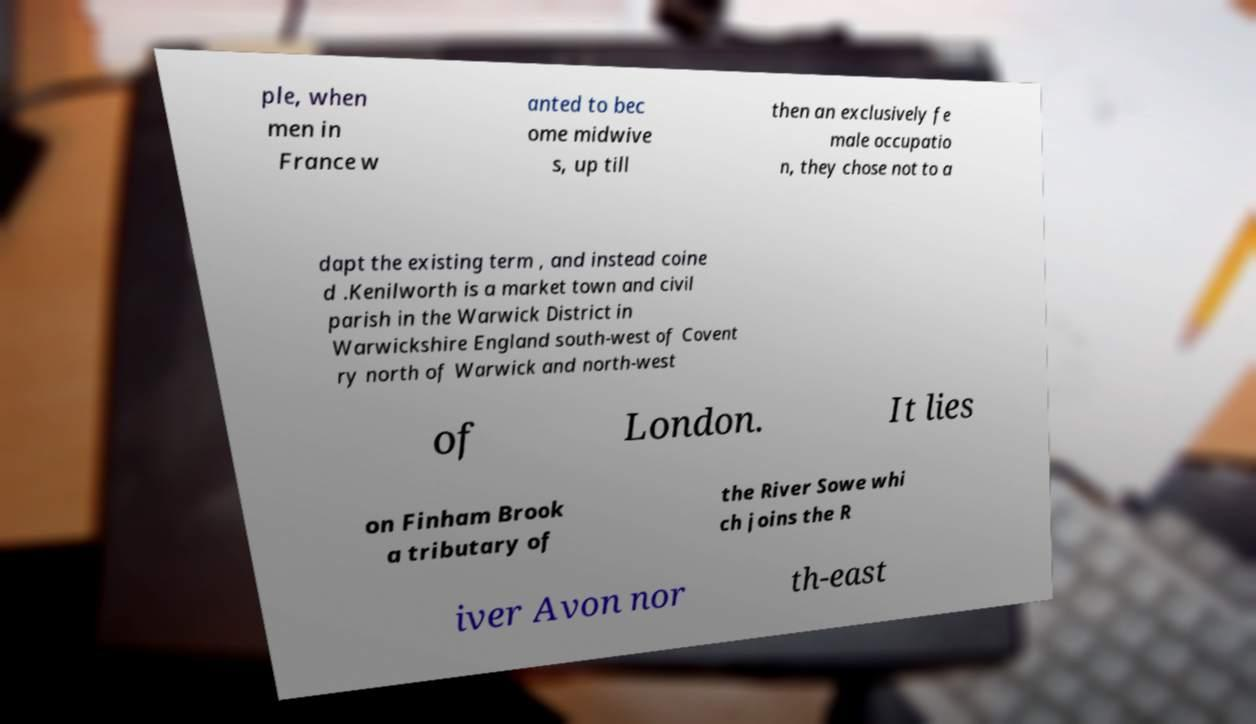For documentation purposes, I need the text within this image transcribed. Could you provide that? ple, when men in France w anted to bec ome midwive s, up till then an exclusively fe male occupatio n, they chose not to a dapt the existing term , and instead coine d .Kenilworth is a market town and civil parish in the Warwick District in Warwickshire England south-west of Covent ry north of Warwick and north-west of London. It lies on Finham Brook a tributary of the River Sowe whi ch joins the R iver Avon nor th-east 